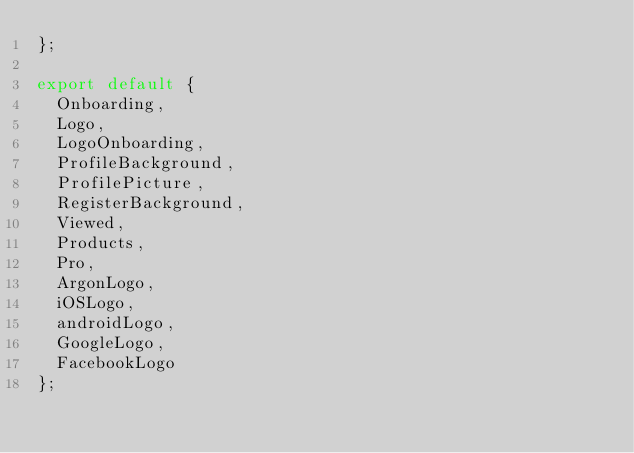Convert code to text. <code><loc_0><loc_0><loc_500><loc_500><_JavaScript_>};

export default {
  Onboarding,
  Logo,
  LogoOnboarding,
  ProfileBackground,
  ProfilePicture,
  RegisterBackground,
  Viewed,
  Products,
  Pro,
  ArgonLogo,
  iOSLogo,
  androidLogo,
  GoogleLogo,
  FacebookLogo
};</code> 